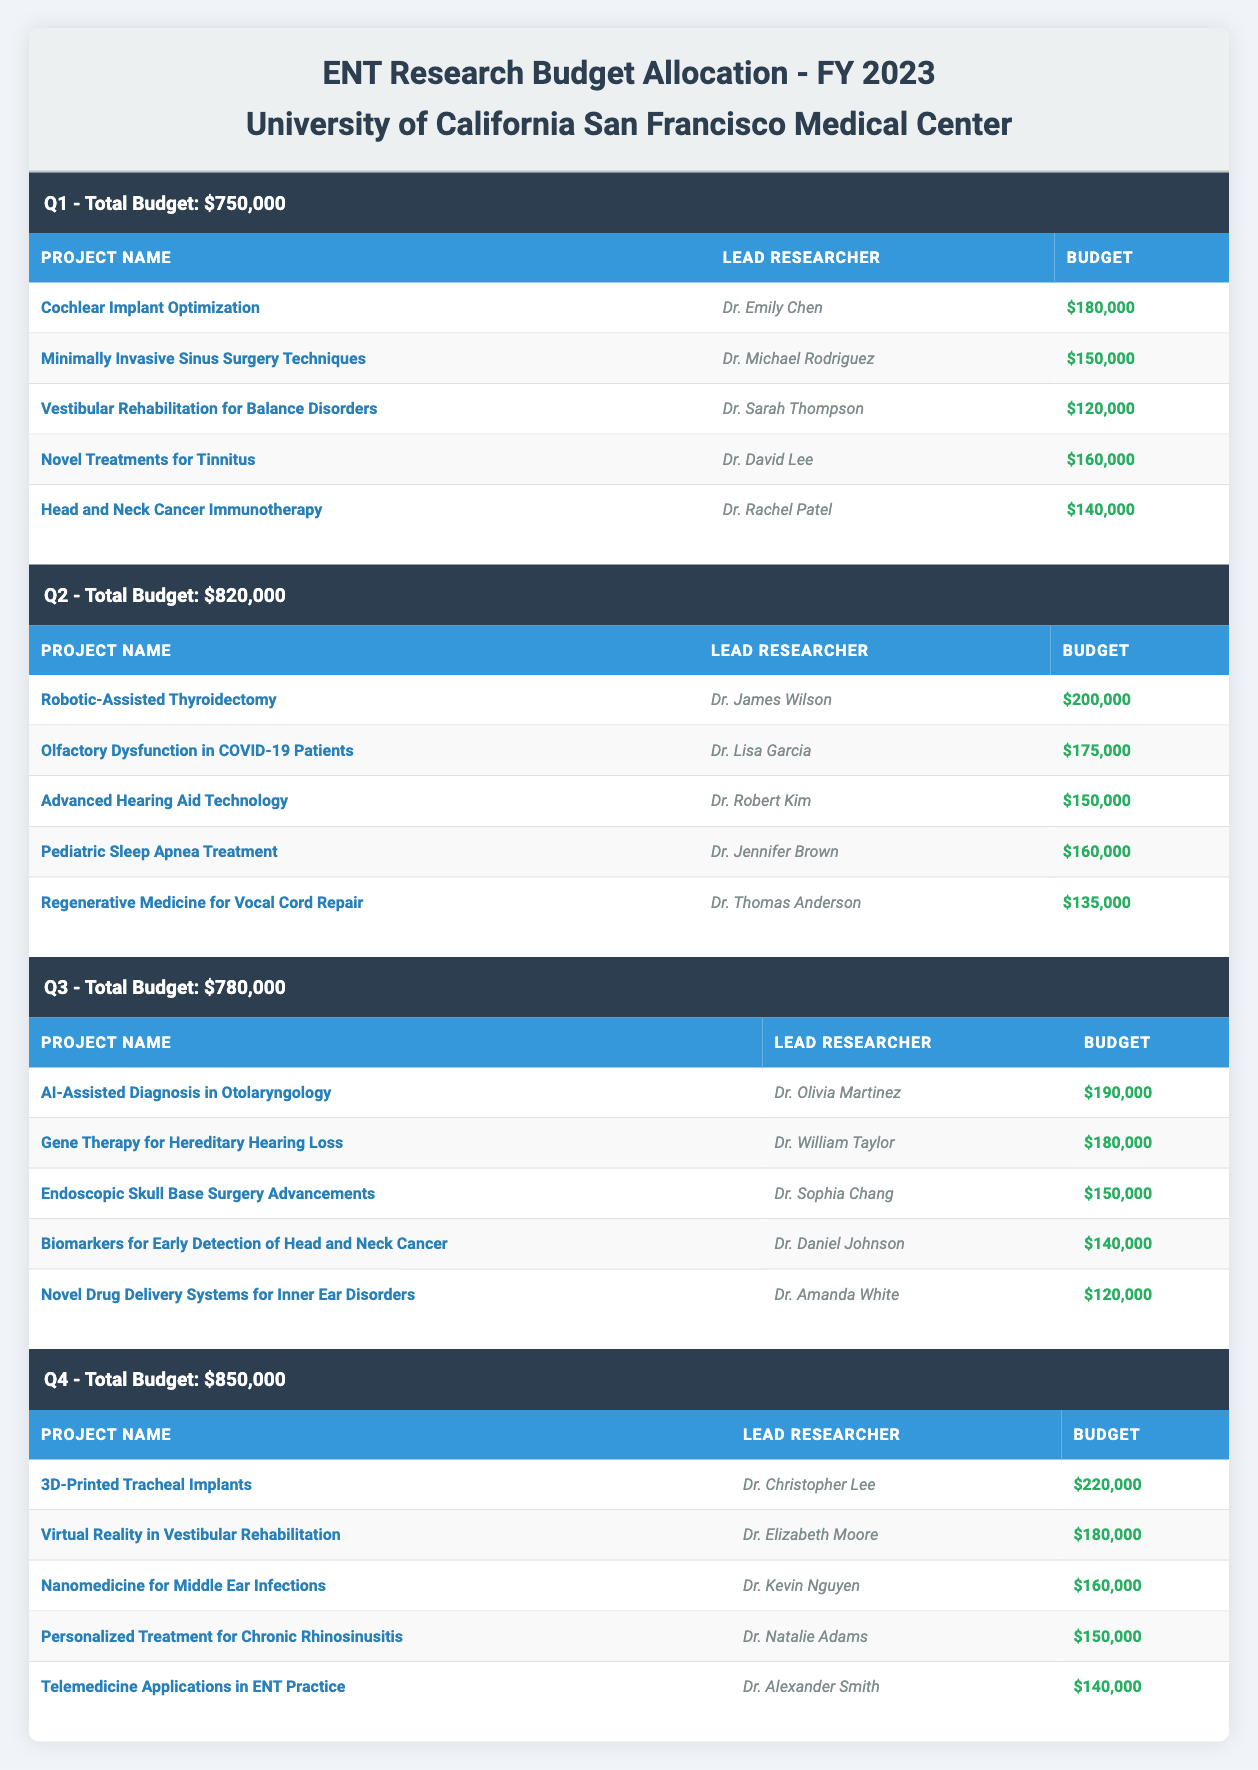What is the total budget allocated for Q1? The total budget for Q1 is listed in the table and is explicitly stated as $750,000.
Answer: $750,000 Which project received the highest budget allocation in Q2? In Q2, the highest budget allocation is for the project "Robotic-Assisted Thyroidectomy," which received $200,000.
Answer: $200,000 How much funding is allocated to "Telemedicine Applications in ENT Practice"? The budget for "Telemedicine Applications in ENT Practice" is found in Q4 under the relevant project section, and it is $140,000.
Answer: $140,000 What is the total budget for all projects in Q3 combined? Adding the budgets for all projects in Q3: $190,000 + $180,000 + $150,000 + $140,000 + $120,000 equals $780,000. Therefore, the total budget for Q3 is confirmed to be $780,000.
Answer: $780,000 Is "Nanomedicine for Middle Ear Infections" allocated less budget than "Pediatric Sleep Apnea Treatment"? Comparing the two projects, "Nanomedicine for Middle Ear Infections" has a budget of $160,000, while "Pediatric Sleep Apnea Treatment" is allocated $160,000 as well. Therefore, the statement is false as they have equal budgets.
Answer: No What is the average budget allocation per project for Q4? In Q4, there are five projects with budgets: $220,000, $180,000, $160,000, $150,000, and $140,000. Adding these amounts gives $850,000, and dividing by the number of projects (5) results in an average of $170,000 per project.
Answer: $170,000 Which researcher is leading the project "Gene Therapy for Hereditary Hearing Loss"? The table specifies that Dr. William Taylor is the lead researcher for the project "Gene Therapy for Hereditary Hearing Loss."
Answer: Dr. William Taylor What is the total budget increase from Q1 to Q4? The total budget for Q1 is $750,000 and for Q4, it's $850,000. The increase can be calculated by subtracting Q1 from Q4: $850,000 - $750,000 = $100,000.
Answer: $100,000 Does any project have a budget allocation of exactly $150,000 in Q3? Reviewing the entries for Q3, "Endoscopic Skull Base Surgery Advancements" has a budget of $150,000. Thus, the statement is true.
Answer: Yes 